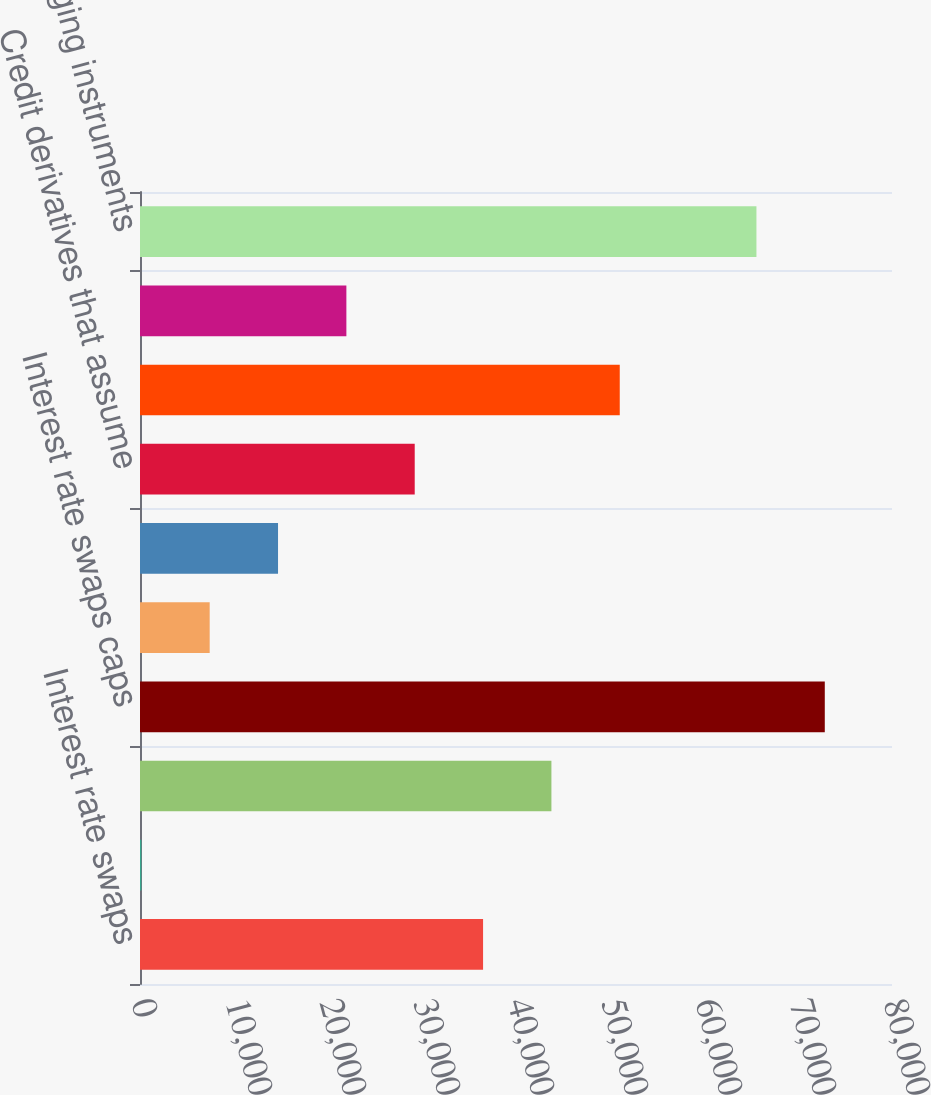Convert chart to OTSL. <chart><loc_0><loc_0><loc_500><loc_500><bar_chart><fcel>Interest rate swaps<fcel>Foreign currency swaps<fcel>Total cash flow hedges<fcel>Interest rate swaps caps<fcel>Foreign currency swaps and<fcel>Credit derivatives that<fcel>Credit derivatives that assume<fcel>Credit derivatives in<fcel>Equity index swaps and options<fcel>GMWB hedging instruments<nl><fcel>36496.5<fcel>143<fcel>43767.2<fcel>72850<fcel>7413.7<fcel>14684.4<fcel>29225.8<fcel>51037.9<fcel>21955.1<fcel>65579.3<nl></chart> 